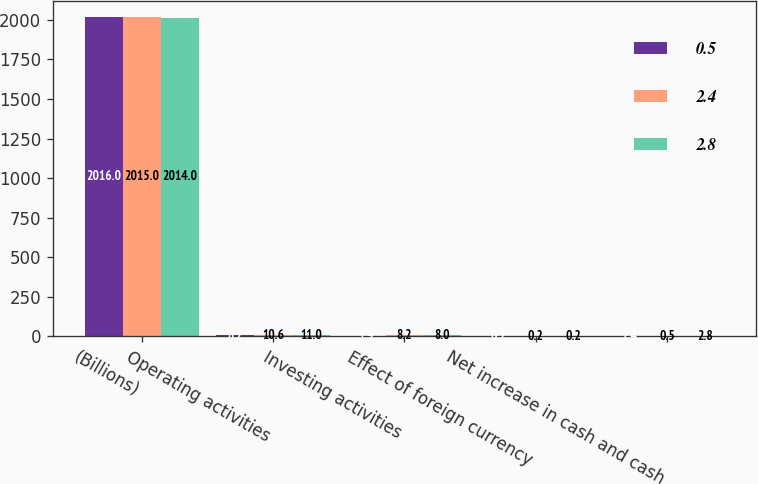<chart> <loc_0><loc_0><loc_500><loc_500><stacked_bar_chart><ecel><fcel>(Billions)<fcel>Operating activities<fcel>Investing activities<fcel>Effect of foreign currency<fcel>Net increase in cash and cash<nl><fcel>0.5<fcel>2016<fcel>8.2<fcel>1.9<fcel>0.2<fcel>2.4<nl><fcel>2.4<fcel>2015<fcel>10.6<fcel>8.2<fcel>0.2<fcel>0.5<nl><fcel>2.8<fcel>2014<fcel>11<fcel>8<fcel>0.2<fcel>2.8<nl></chart> 